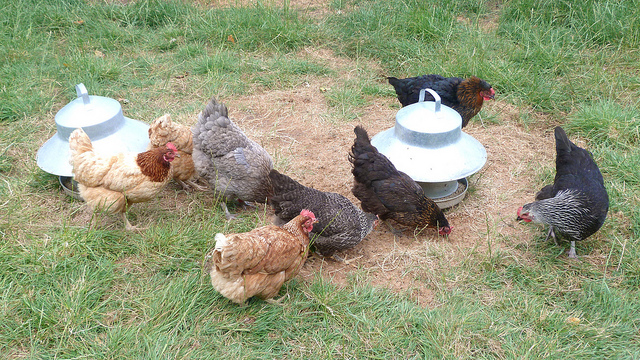<image>How many roosters are eating? I am not sure how many roosters are eating. How many roosters are eating? I don't know how many roosters are eating. It can be either 4, 2 or 0. 